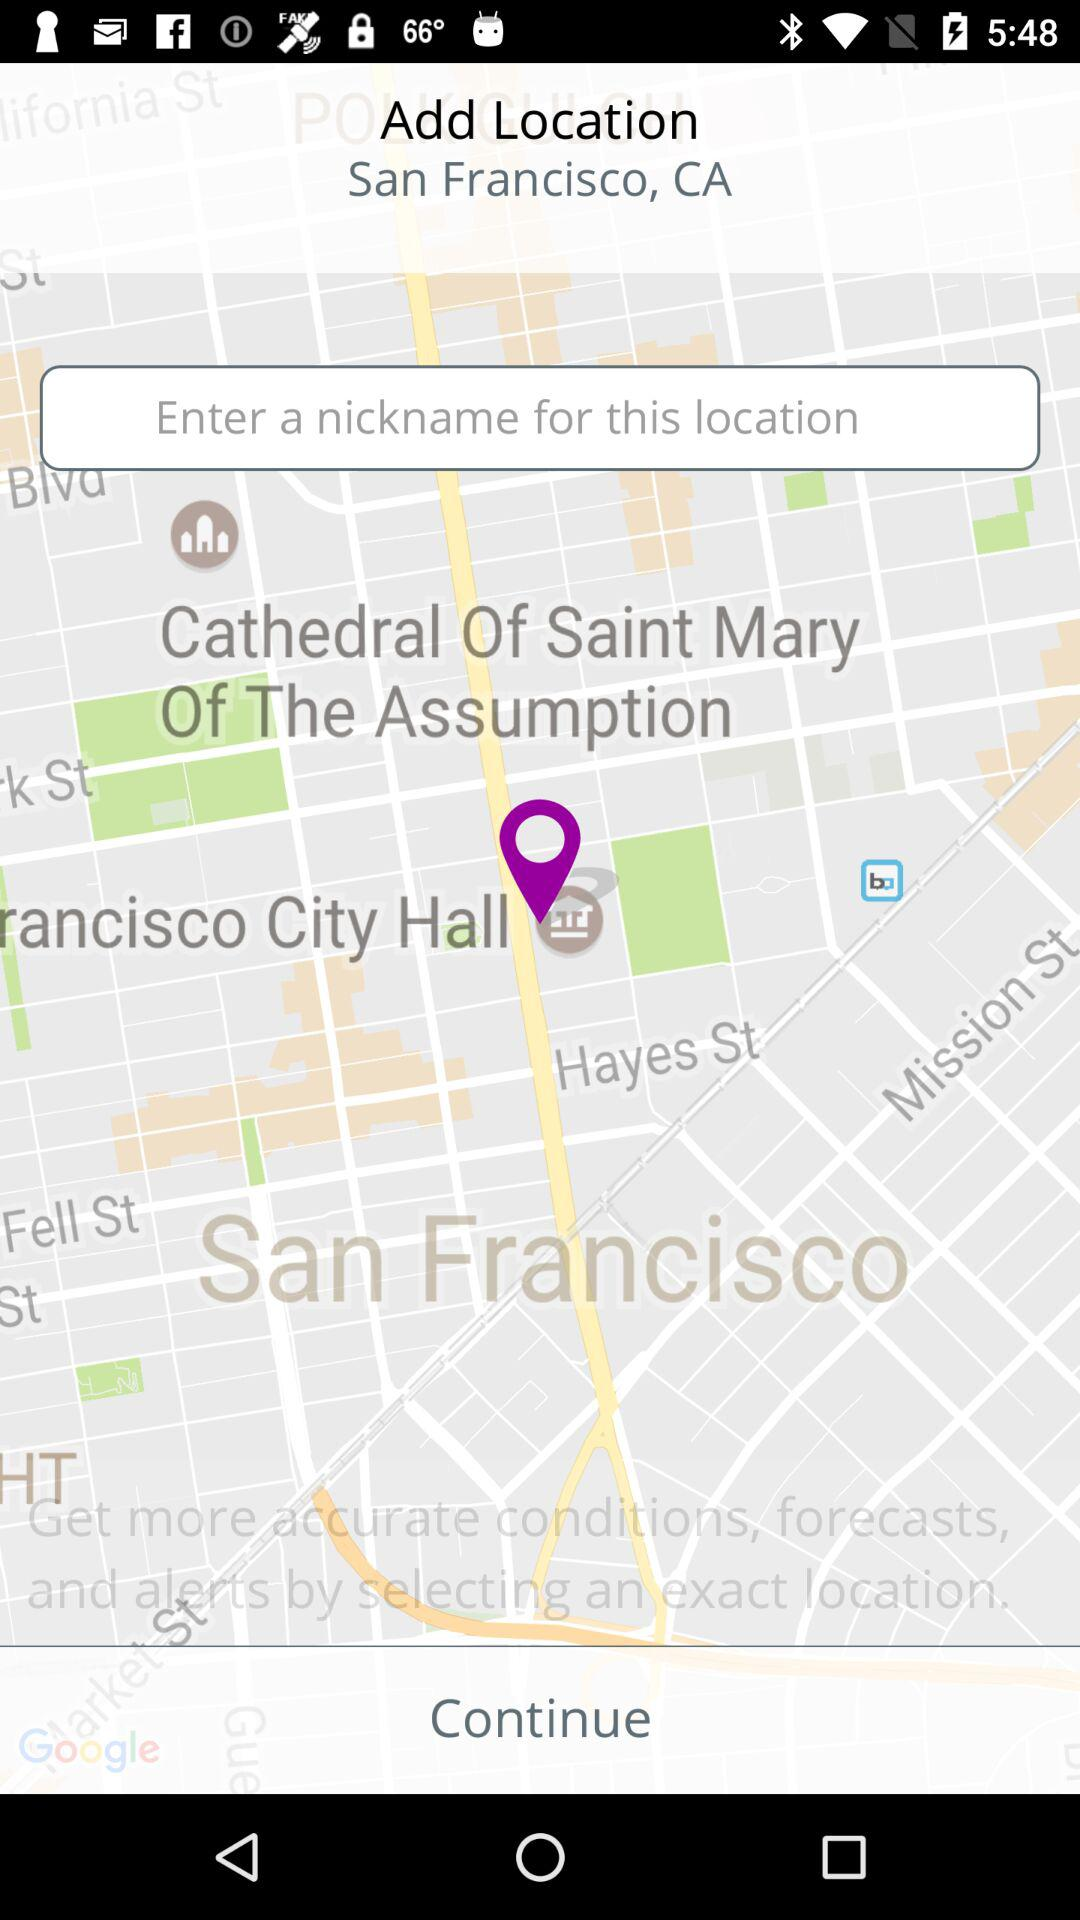What is the given location? The given location is San Francisco, CA. 